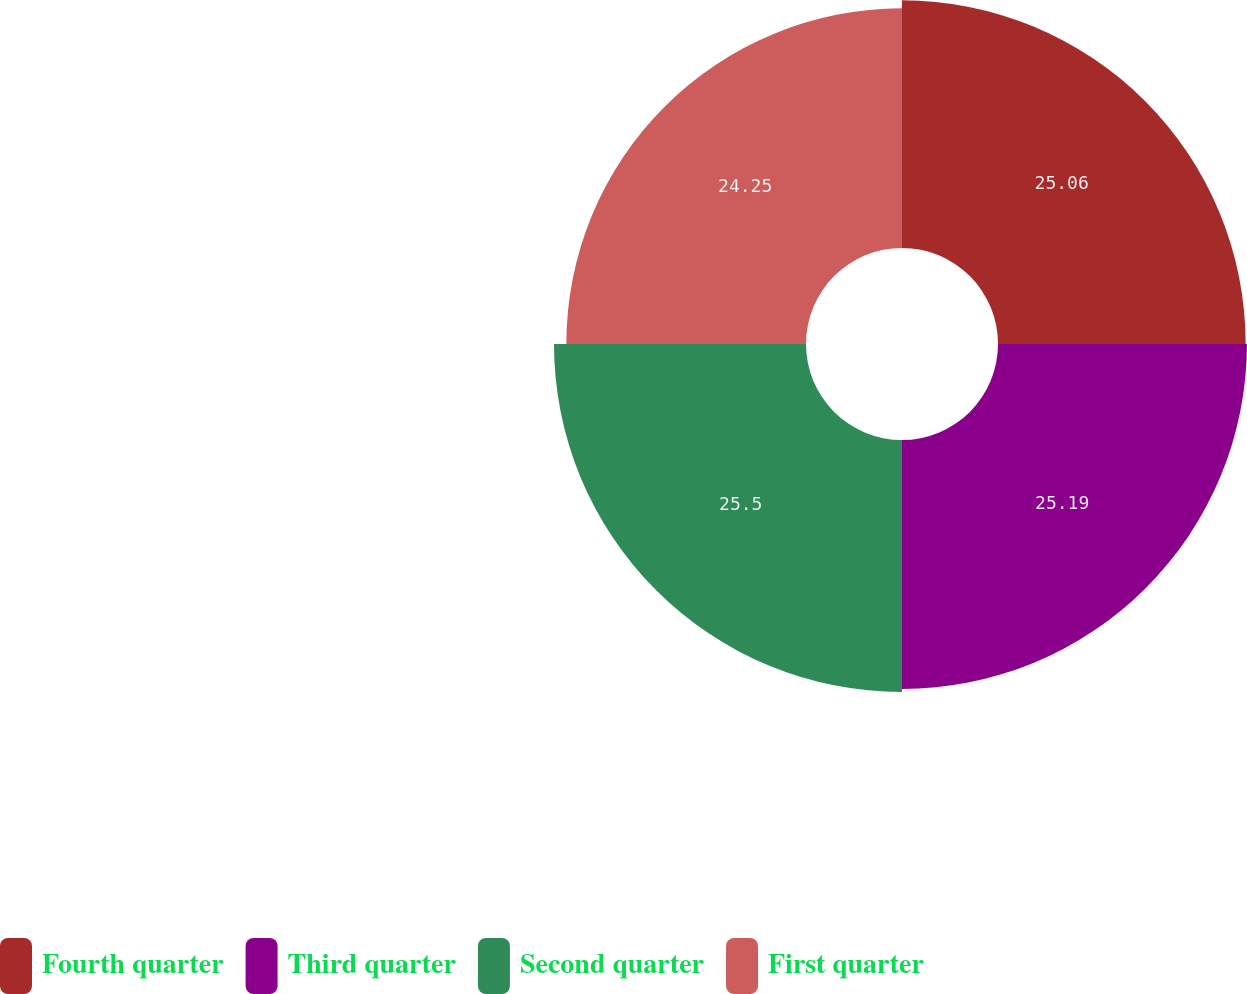<chart> <loc_0><loc_0><loc_500><loc_500><pie_chart><fcel>Fourth quarter<fcel>Third quarter<fcel>Second quarter<fcel>First quarter<nl><fcel>25.06%<fcel>25.19%<fcel>25.5%<fcel>24.25%<nl></chart> 